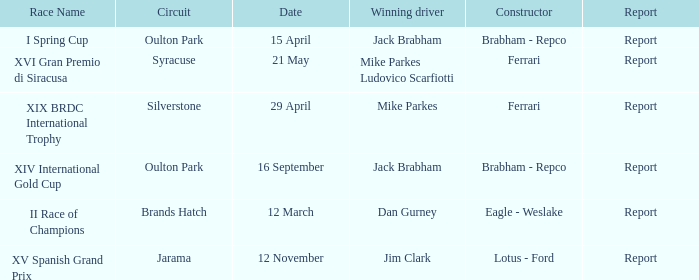What date was the xiv international gold cup? 16 September. 